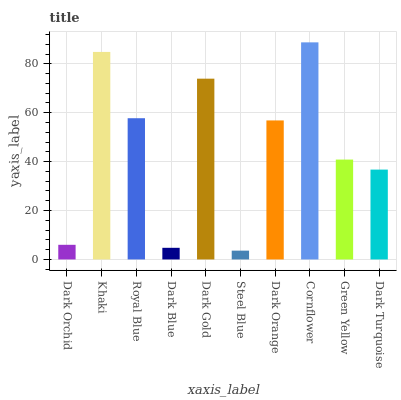Is Khaki the minimum?
Answer yes or no. No. Is Khaki the maximum?
Answer yes or no. No. Is Khaki greater than Dark Orchid?
Answer yes or no. Yes. Is Dark Orchid less than Khaki?
Answer yes or no. Yes. Is Dark Orchid greater than Khaki?
Answer yes or no. No. Is Khaki less than Dark Orchid?
Answer yes or no. No. Is Dark Orange the high median?
Answer yes or no. Yes. Is Green Yellow the low median?
Answer yes or no. Yes. Is Royal Blue the high median?
Answer yes or no. No. Is Dark Blue the low median?
Answer yes or no. No. 